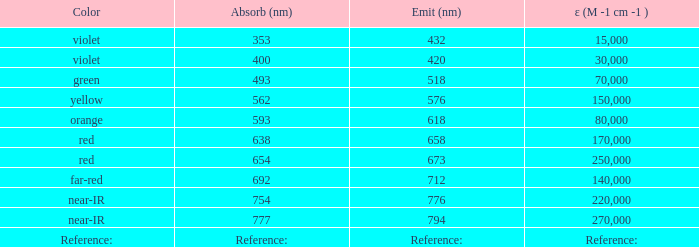Which Emission (in nanometers) has an absorbtion of 593 nm? 618.0. 